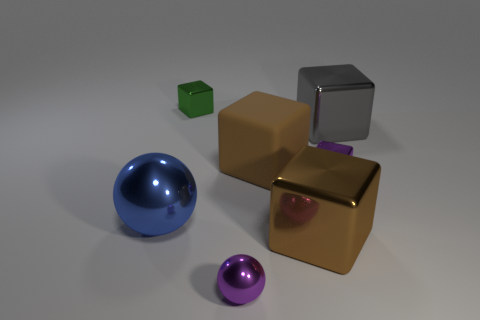Subtract all gray blocks. How many blocks are left? 4 Subtract all matte cubes. How many cubes are left? 4 Subtract all red cubes. Subtract all gray spheres. How many cubes are left? 5 Add 2 small red matte things. How many objects exist? 9 Subtract all spheres. How many objects are left? 5 Subtract all brown blocks. Subtract all tiny green cubes. How many objects are left? 4 Add 4 large blue spheres. How many large blue spheres are left? 5 Add 7 tiny purple metal cubes. How many tiny purple metal cubes exist? 8 Subtract 0 brown cylinders. How many objects are left? 7 